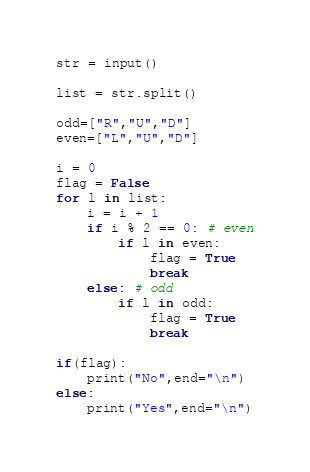Convert code to text. <code><loc_0><loc_0><loc_500><loc_500><_Python_>str = input()

list = str.split()

odd=["R","U","D"]
even=["L","U","D"]

i = 0
flag = False
for l in list:
    i = i + 1
    if i % 2 == 0: # even
        if l in even:
            flag = True
            break
    else: # odd
        if l in odd:
            flag = True
            break

if(flag):
    print("No",end="\n")
else:
    print("Yes",end="\n")</code> 